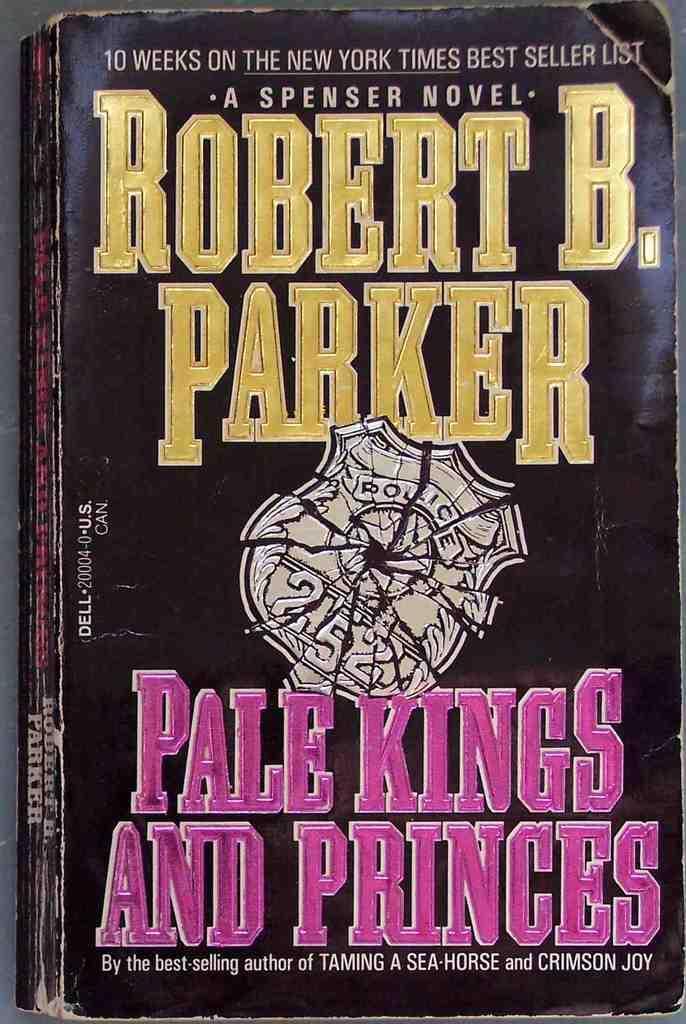Can you describe this image briefly? In this picture we can see a book. 